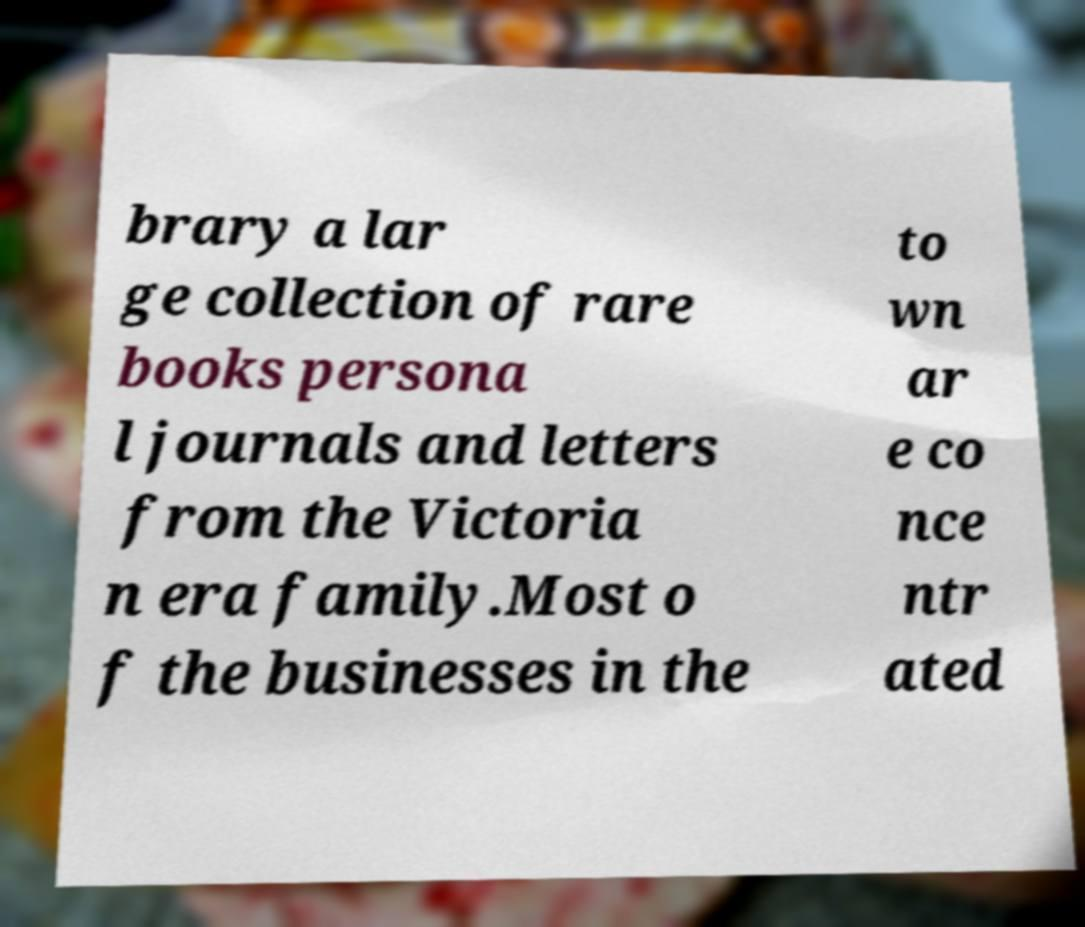Please identify and transcribe the text found in this image. brary a lar ge collection of rare books persona l journals and letters from the Victoria n era family.Most o f the businesses in the to wn ar e co nce ntr ated 